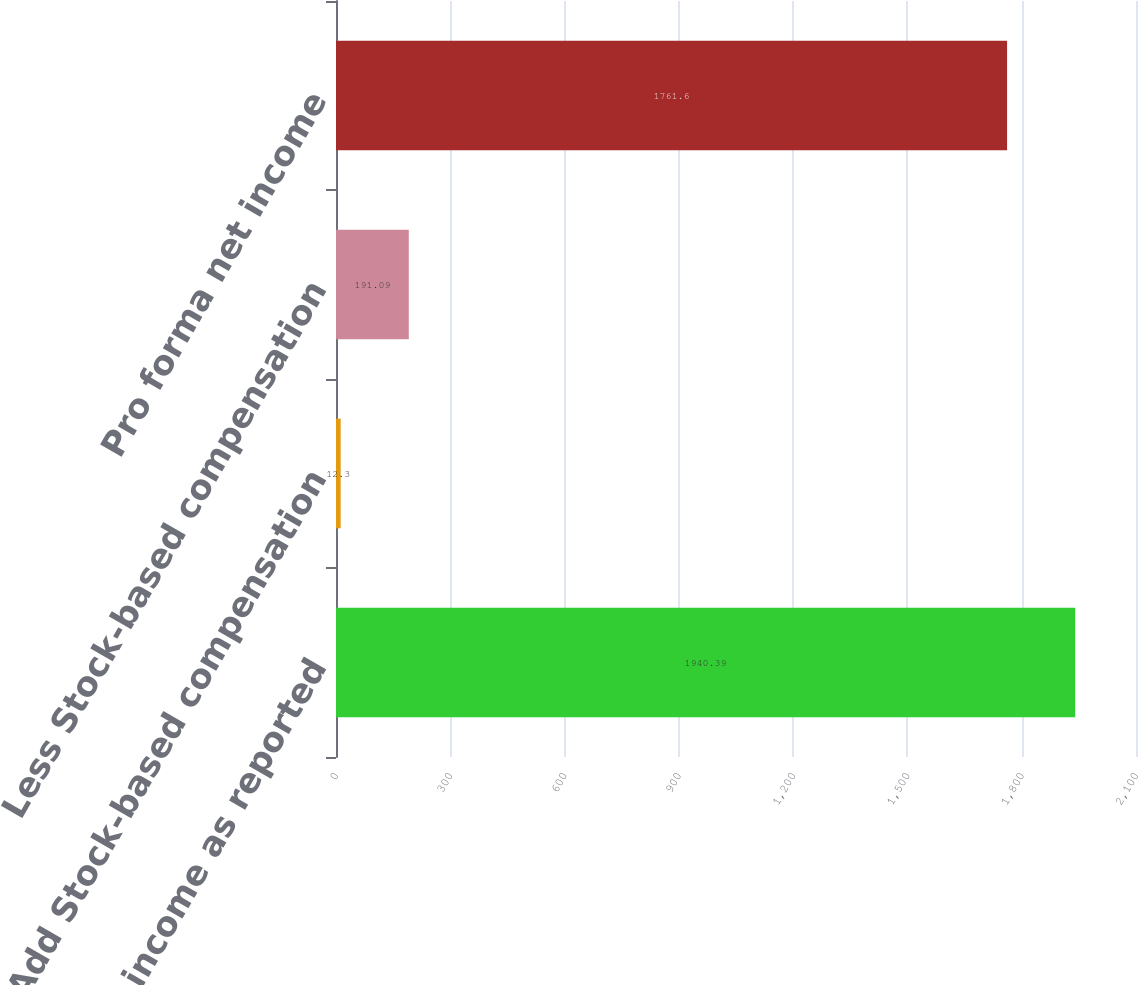<chart> <loc_0><loc_0><loc_500><loc_500><bar_chart><fcel>Net income as reported<fcel>Add Stock-based compensation<fcel>Less Stock-based compensation<fcel>Pro forma net income<nl><fcel>1940.39<fcel>12.3<fcel>191.09<fcel>1761.6<nl></chart> 